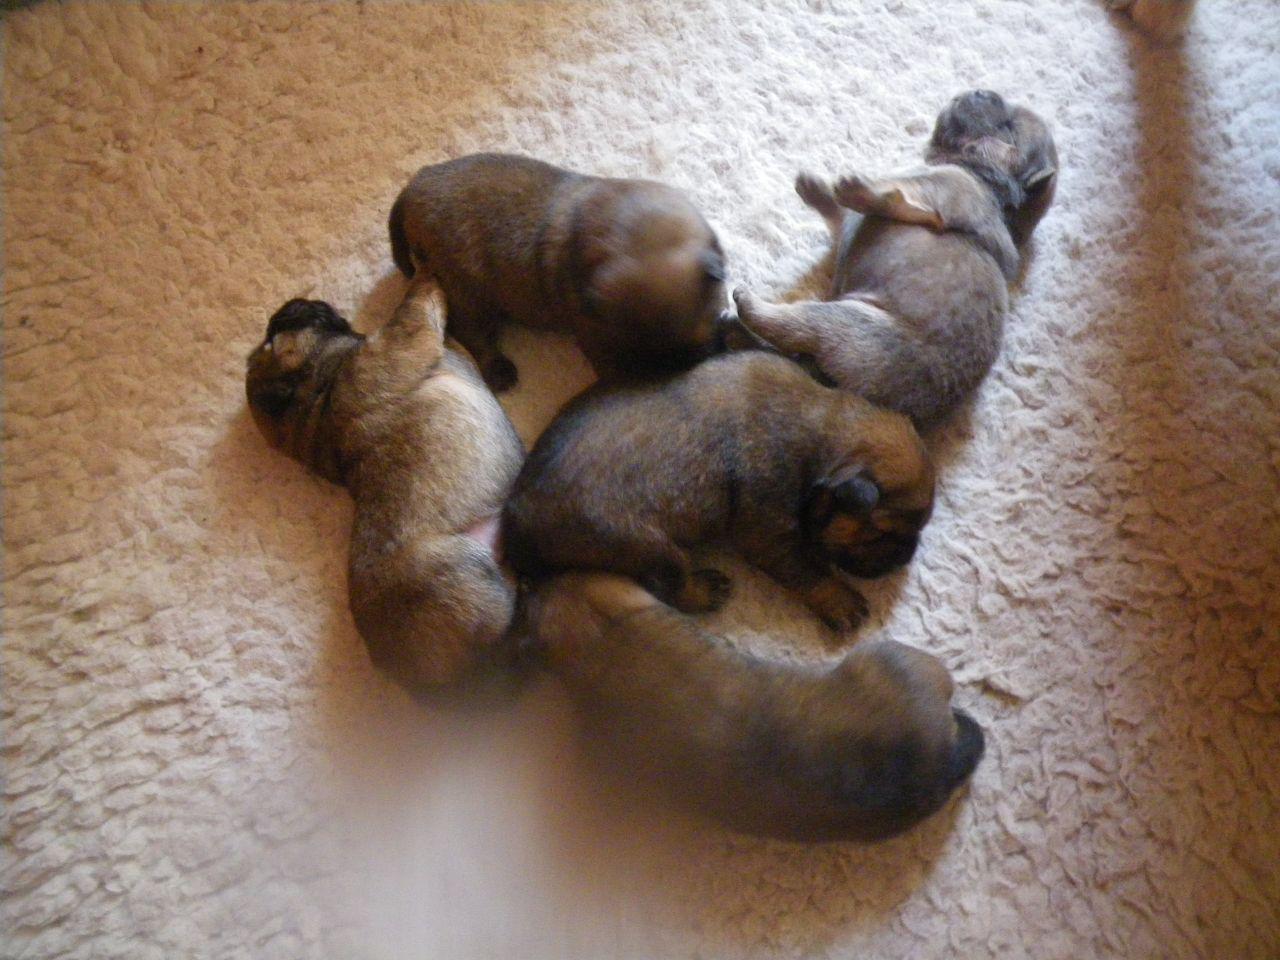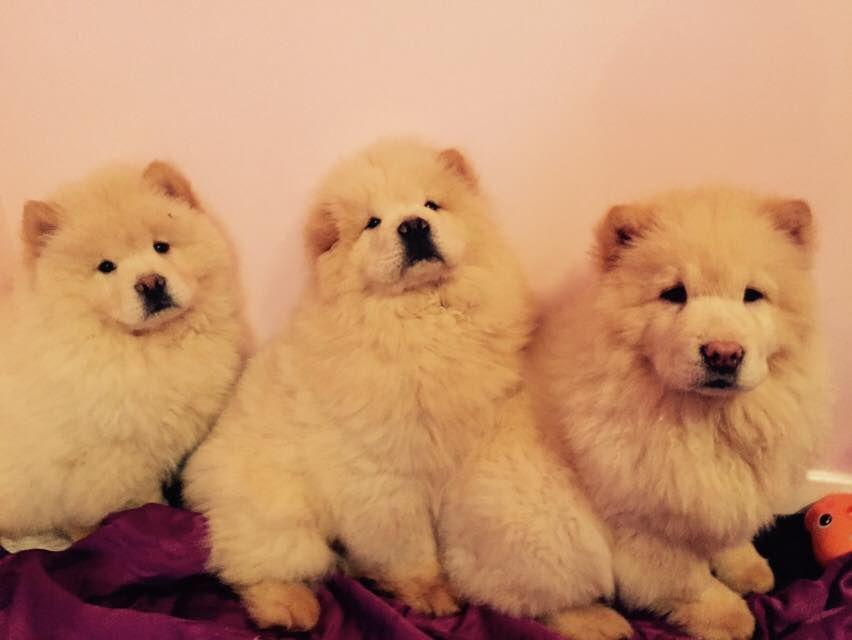The first image is the image on the left, the second image is the image on the right. Assess this claim about the two images: "All images show multiple chow puppies, and the left image contains at least five camera-facing puppies.". Correct or not? Answer yes or no. No. 